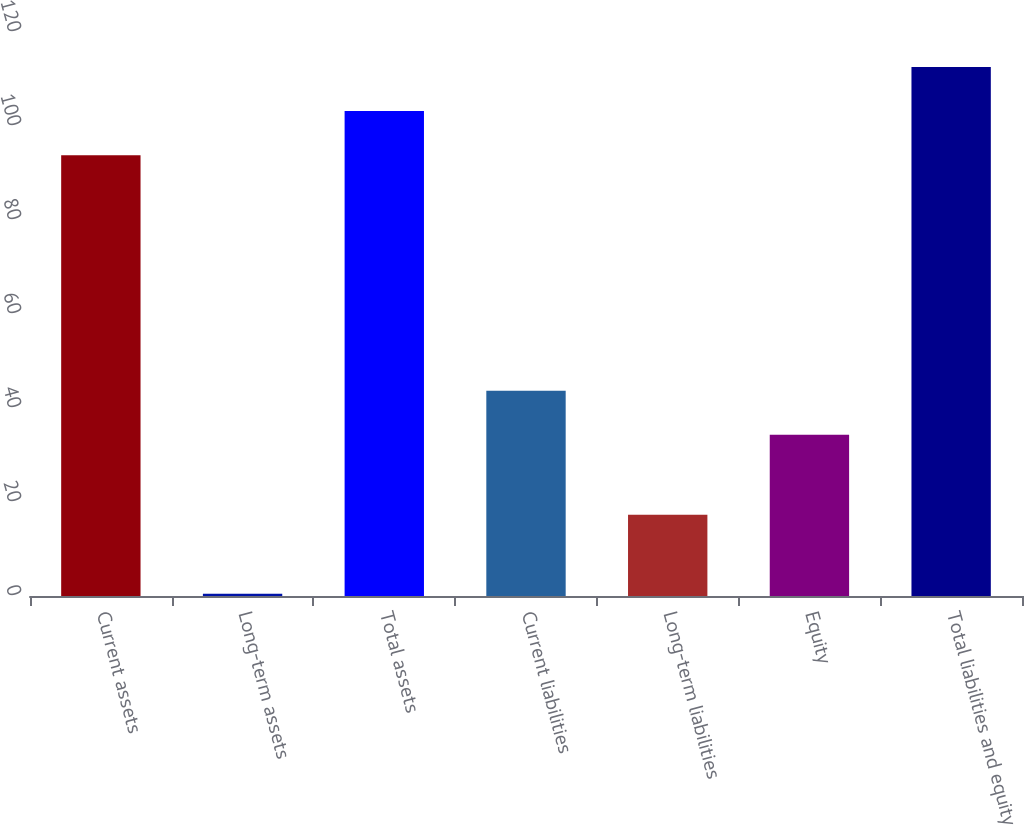Convert chart to OTSL. <chart><loc_0><loc_0><loc_500><loc_500><bar_chart><fcel>Current assets<fcel>Long-term assets<fcel>Total assets<fcel>Current liabilities<fcel>Long-term liabilities<fcel>Equity<fcel>Total liabilities and equity<nl><fcel>93.8<fcel>0.5<fcel>103.18<fcel>43.68<fcel>17.3<fcel>34.3<fcel>112.56<nl></chart> 